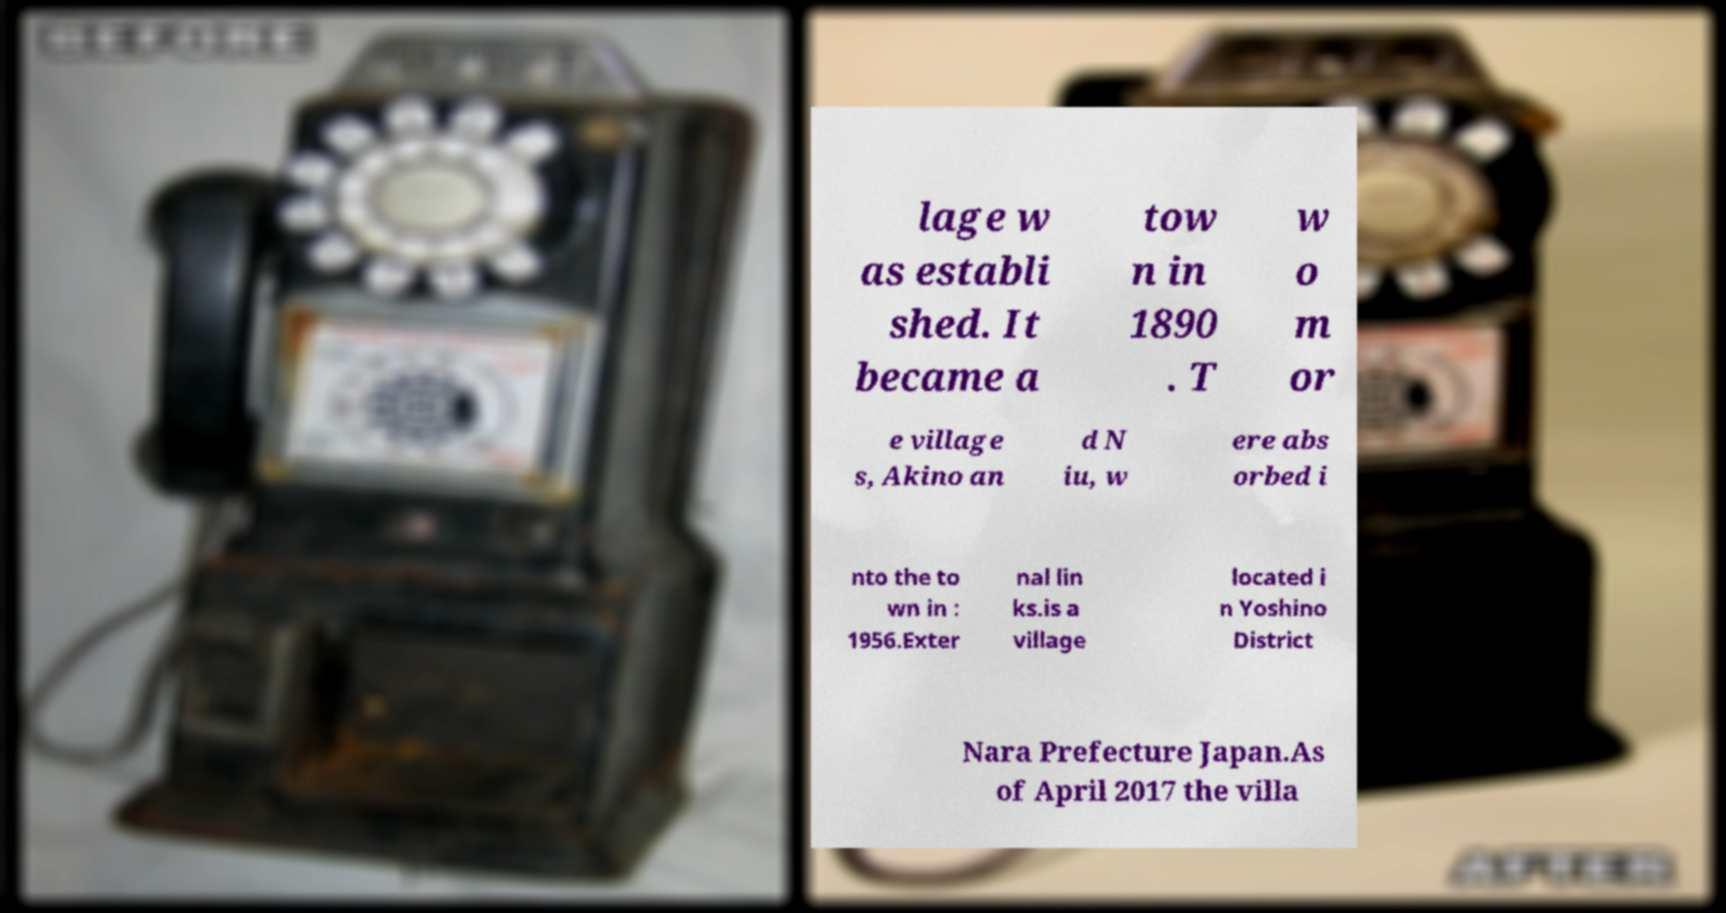Please read and relay the text visible in this image. What does it say? lage w as establi shed. It became a tow n in 1890 . T w o m or e village s, Akino an d N iu, w ere abs orbed i nto the to wn in : 1956.Exter nal lin ks.is a village located i n Yoshino District Nara Prefecture Japan.As of April 2017 the villa 